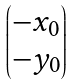Convert formula to latex. <formula><loc_0><loc_0><loc_500><loc_500>\begin{pmatrix} - x _ { 0 } \\ - y _ { 0 } \end{pmatrix}</formula> 